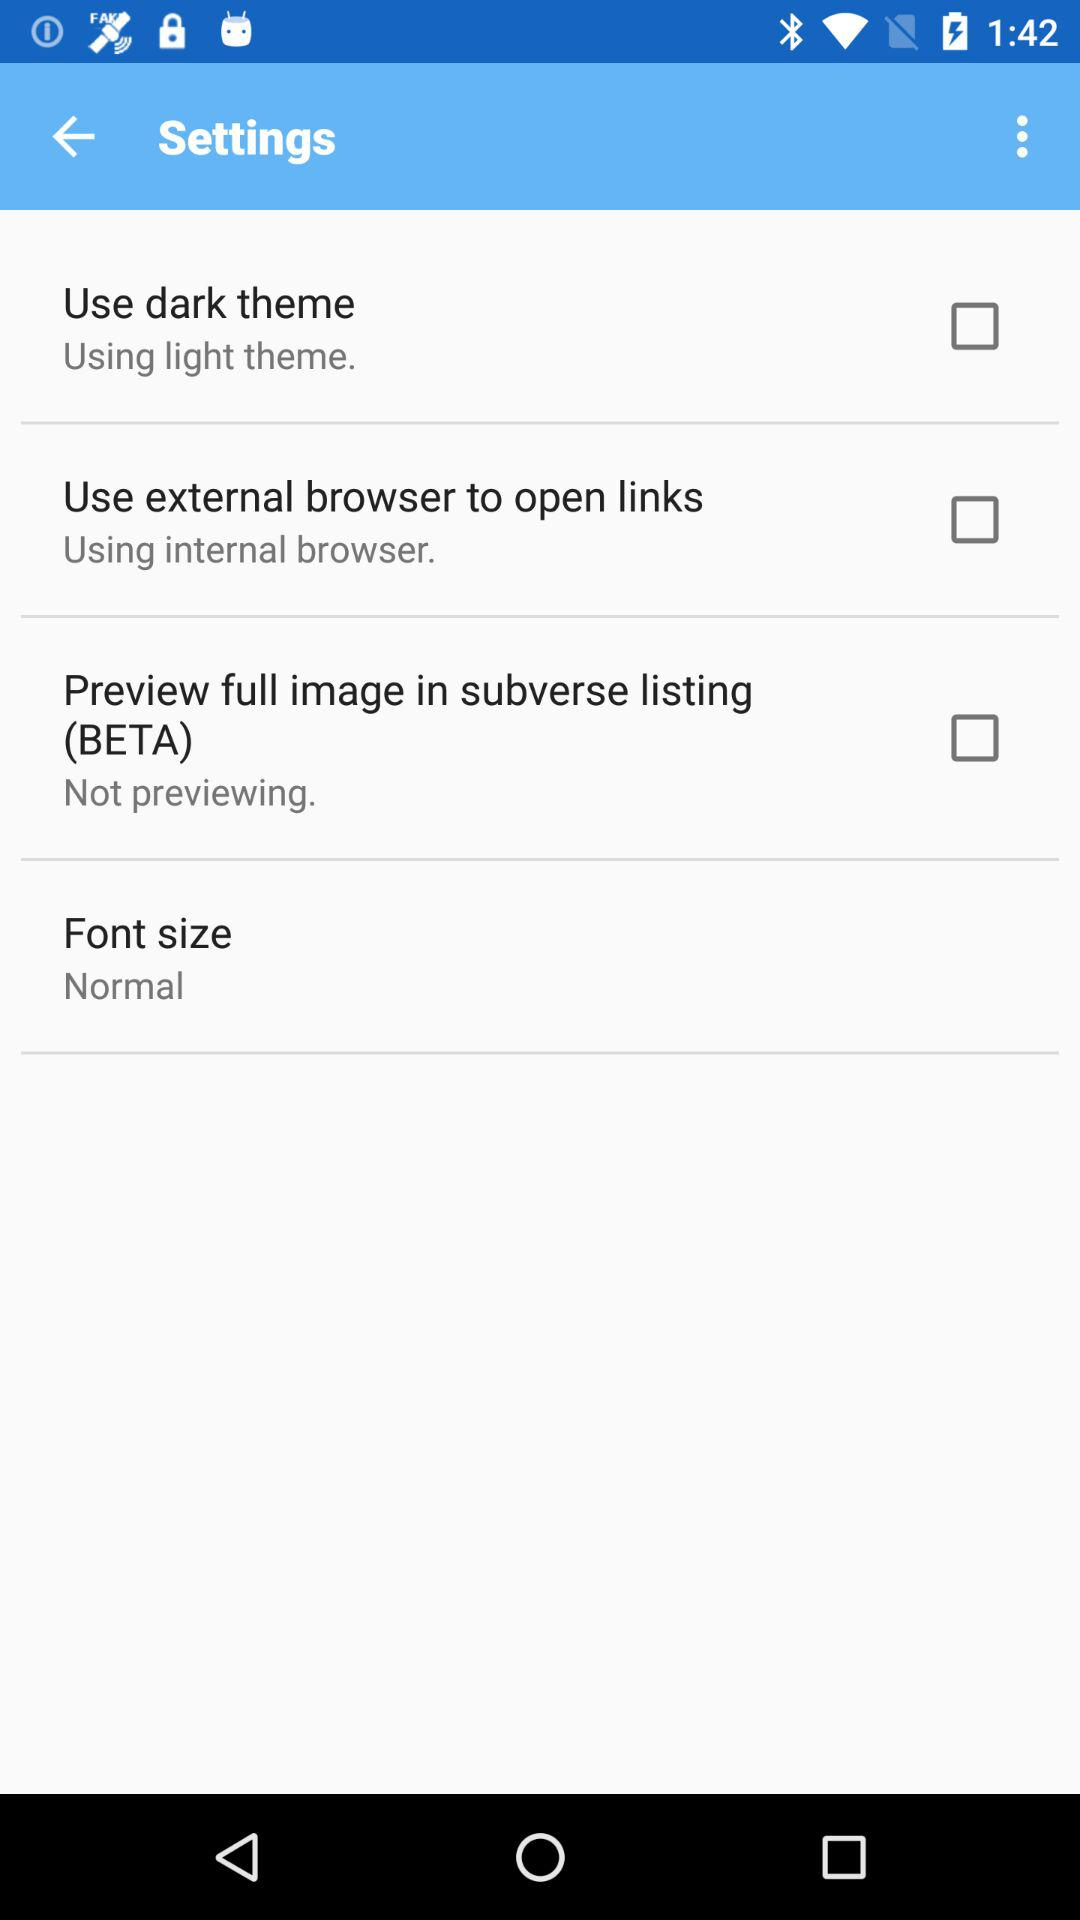What is the status of "Preview full image in subverse listing"? The status of "Preview full image in subverse listing" is "off". 